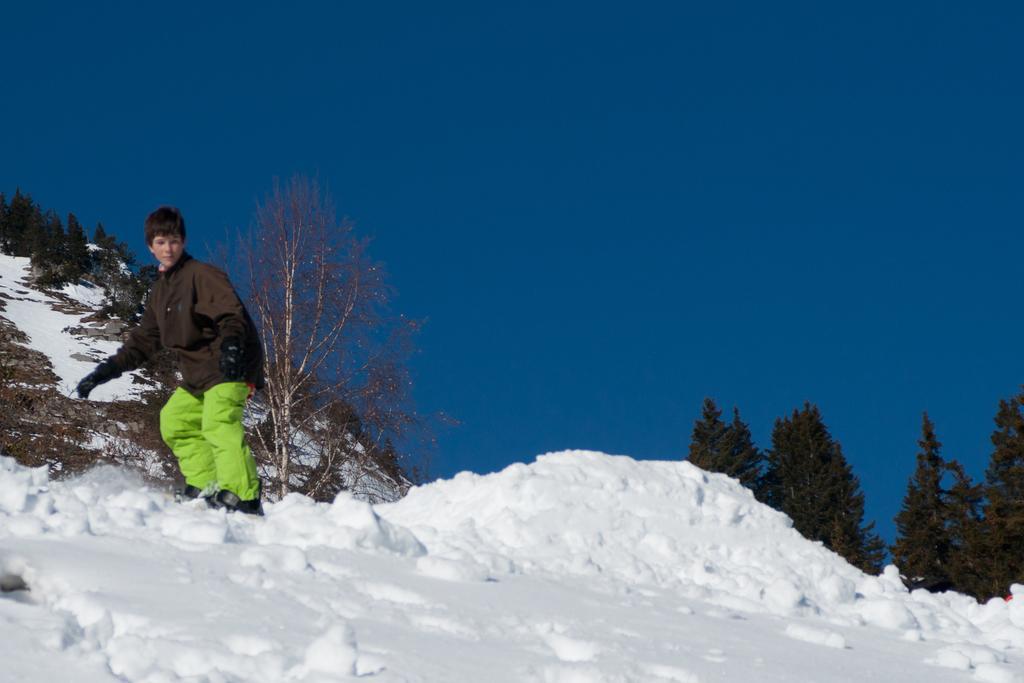Please provide a concise description of this image. In the foreground there is snow. On the left there is a person skating. In the background towards left there are trees and hill. On the right there are trees. Sky is clear. 